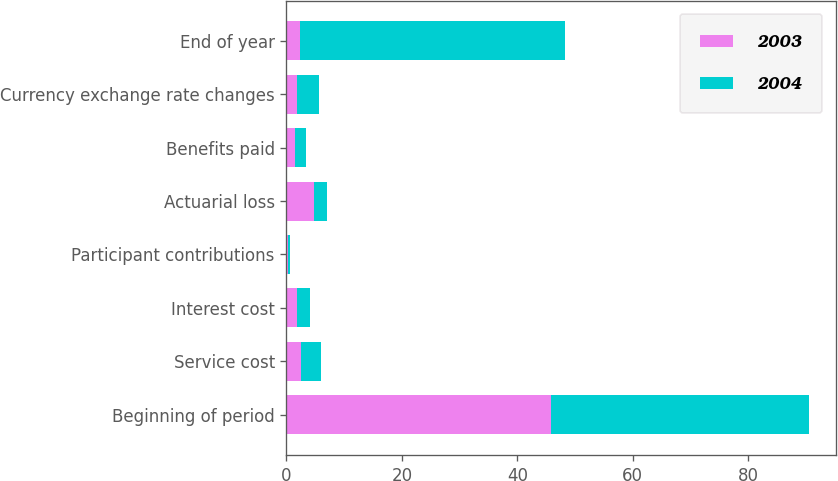Convert chart. <chart><loc_0><loc_0><loc_500><loc_500><stacked_bar_chart><ecel><fcel>Beginning of period<fcel>Service cost<fcel>Interest cost<fcel>Participant contributions<fcel>Actuarial loss<fcel>Benefits paid<fcel>Currency exchange rate changes<fcel>End of year<nl><fcel>2003<fcel>45.9<fcel>2.6<fcel>1.9<fcel>0.2<fcel>4.8<fcel>1.4<fcel>1.9<fcel>2.3<nl><fcel>2004<fcel>44.7<fcel>3.3<fcel>2.2<fcel>0.4<fcel>2.3<fcel>2<fcel>3.7<fcel>45.9<nl></chart> 